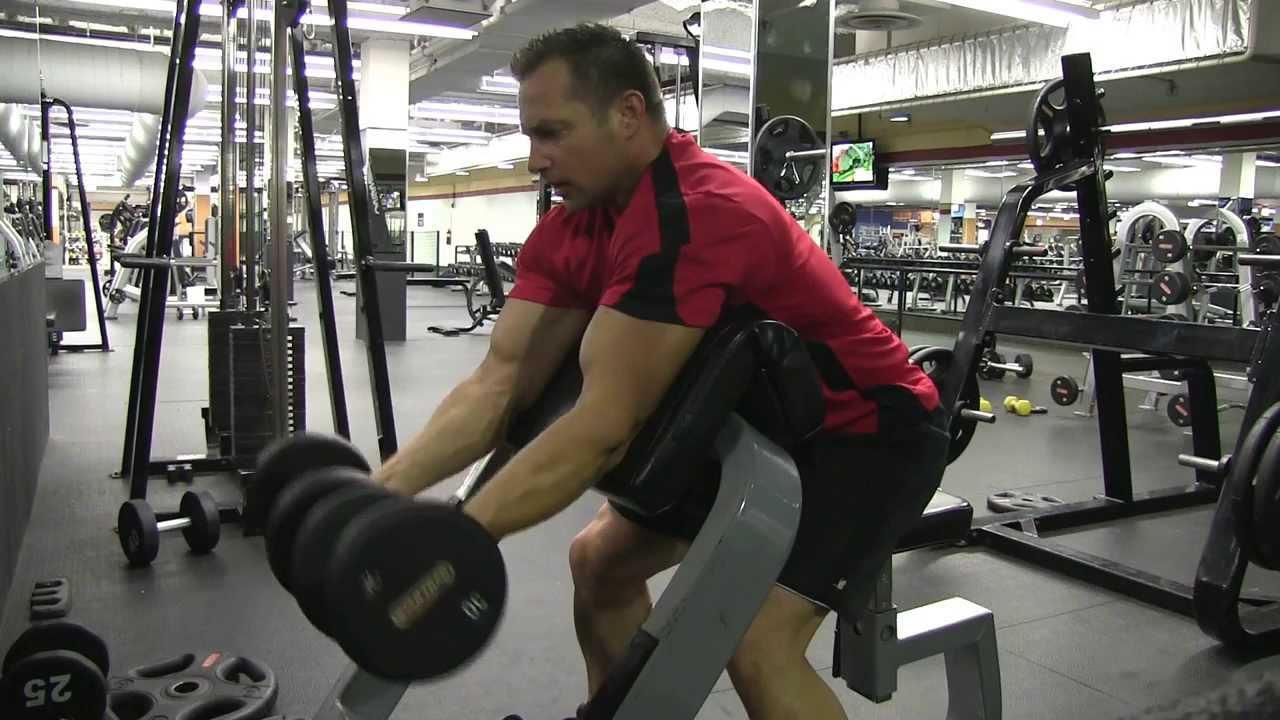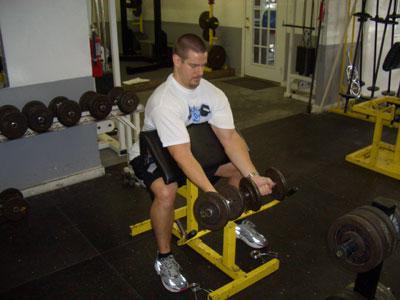The first image is the image on the left, the second image is the image on the right. For the images displayed, is the sentence "there is a male with a dumbbell near his face" factually correct? Answer yes or no. No. 